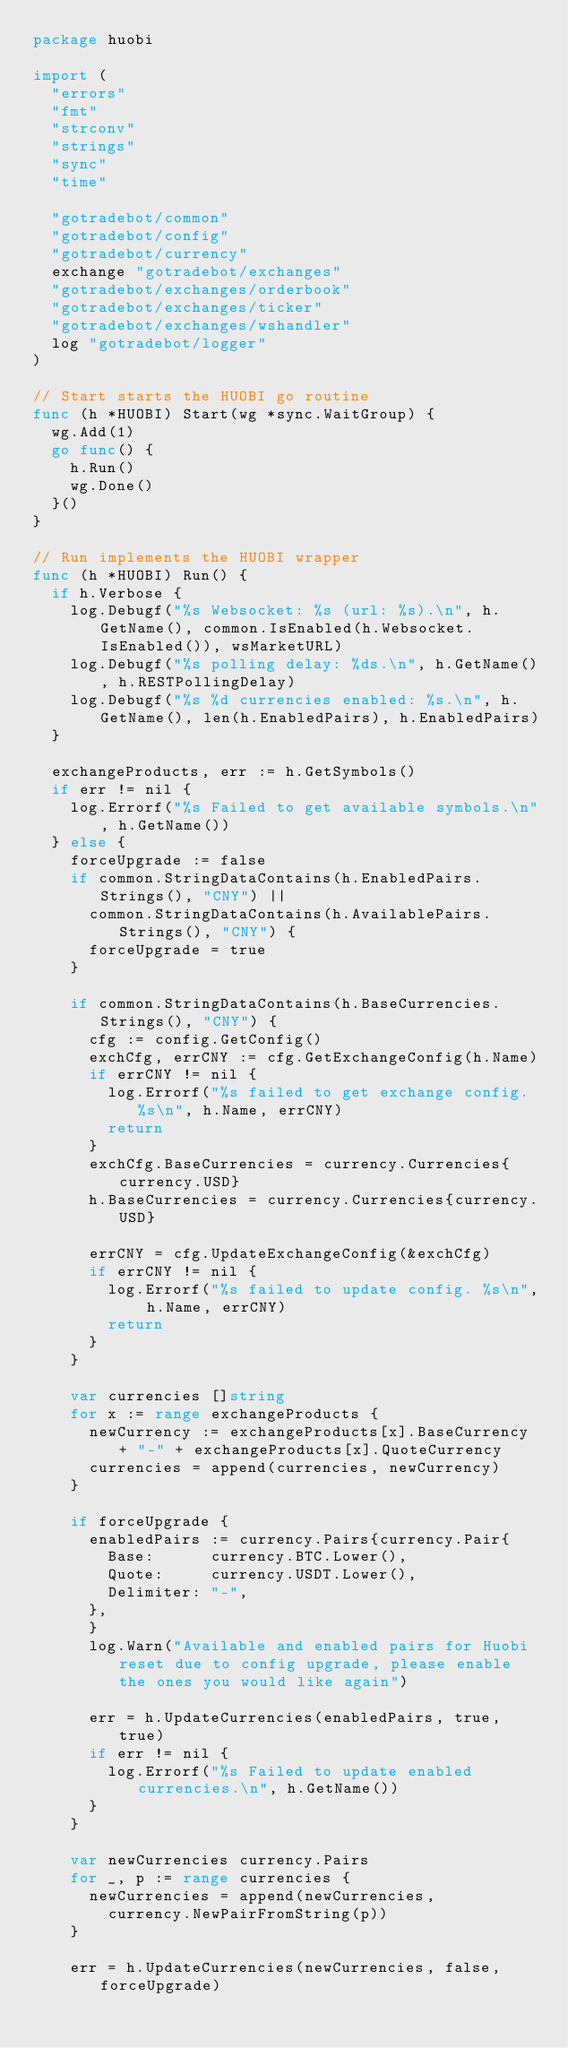<code> <loc_0><loc_0><loc_500><loc_500><_Go_>package huobi

import (
	"errors"
	"fmt"
	"strconv"
	"strings"
	"sync"
	"time"

	"gotradebot/common"
	"gotradebot/config"
	"gotradebot/currency"
	exchange "gotradebot/exchanges"
	"gotradebot/exchanges/orderbook"
	"gotradebot/exchanges/ticker"
	"gotradebot/exchanges/wshandler"
	log "gotradebot/logger"
)

// Start starts the HUOBI go routine
func (h *HUOBI) Start(wg *sync.WaitGroup) {
	wg.Add(1)
	go func() {
		h.Run()
		wg.Done()
	}()
}

// Run implements the HUOBI wrapper
func (h *HUOBI) Run() {
	if h.Verbose {
		log.Debugf("%s Websocket: %s (url: %s).\n", h.GetName(), common.IsEnabled(h.Websocket.IsEnabled()), wsMarketURL)
		log.Debugf("%s polling delay: %ds.\n", h.GetName(), h.RESTPollingDelay)
		log.Debugf("%s %d currencies enabled: %s.\n", h.GetName(), len(h.EnabledPairs), h.EnabledPairs)
	}

	exchangeProducts, err := h.GetSymbols()
	if err != nil {
		log.Errorf("%s Failed to get available symbols.\n", h.GetName())
	} else {
		forceUpgrade := false
		if common.StringDataContains(h.EnabledPairs.Strings(), "CNY") ||
			common.StringDataContains(h.AvailablePairs.Strings(), "CNY") {
			forceUpgrade = true
		}

		if common.StringDataContains(h.BaseCurrencies.Strings(), "CNY") {
			cfg := config.GetConfig()
			exchCfg, errCNY := cfg.GetExchangeConfig(h.Name)
			if errCNY != nil {
				log.Errorf("%s failed to get exchange config. %s\n", h.Name, errCNY)
				return
			}
			exchCfg.BaseCurrencies = currency.Currencies{currency.USD}
			h.BaseCurrencies = currency.Currencies{currency.USD}

			errCNY = cfg.UpdateExchangeConfig(&exchCfg)
			if errCNY != nil {
				log.Errorf("%s failed to update config. %s\n", h.Name, errCNY)
				return
			}
		}

		var currencies []string
		for x := range exchangeProducts {
			newCurrency := exchangeProducts[x].BaseCurrency + "-" + exchangeProducts[x].QuoteCurrency
			currencies = append(currencies, newCurrency)
		}

		if forceUpgrade {
			enabledPairs := currency.Pairs{currency.Pair{
				Base:      currency.BTC.Lower(),
				Quote:     currency.USDT.Lower(),
				Delimiter: "-",
			},
			}
			log.Warn("Available and enabled pairs for Huobi reset due to config upgrade, please enable the ones you would like again")

			err = h.UpdateCurrencies(enabledPairs, true, true)
			if err != nil {
				log.Errorf("%s Failed to update enabled currencies.\n", h.GetName())
			}
		}

		var newCurrencies currency.Pairs
		for _, p := range currencies {
			newCurrencies = append(newCurrencies,
				currency.NewPairFromString(p))
		}

		err = h.UpdateCurrencies(newCurrencies, false, forceUpgrade)</code> 